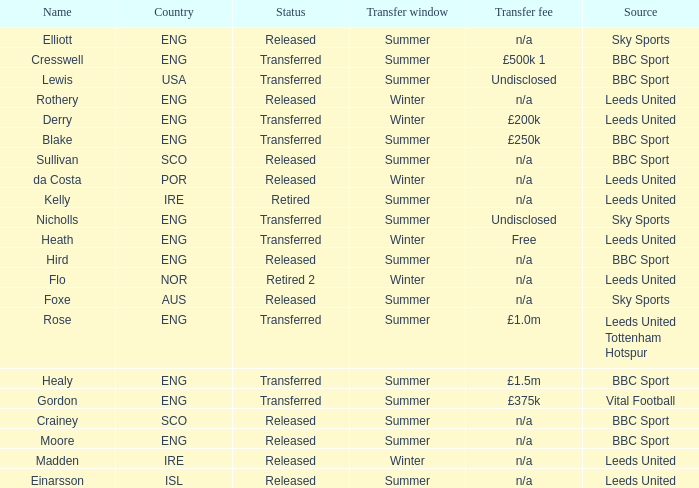What was the transfer fee for the summer transfer involving the SCO named Crainey? N/a. 